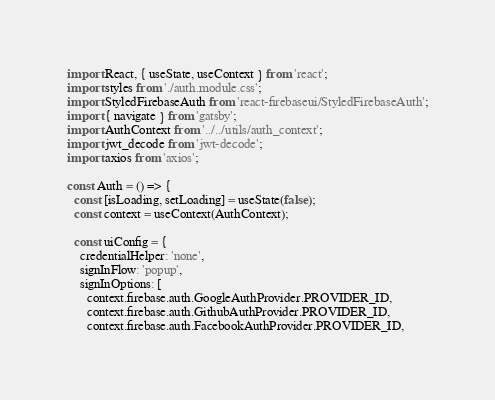Convert code to text. <code><loc_0><loc_0><loc_500><loc_500><_JavaScript_>import React, { useState, useContext } from 'react';
import styles from './auth.module.css';
import StyledFirebaseAuth from 'react-firebaseui/StyledFirebaseAuth';
import { navigate } from 'gatsby';
import AuthContext from '../../utils/auth_context';
import jwt_decode from 'jwt-decode';
import axios from 'axios';

const Auth = () => {
  const [isLoading, setLoading] = useState(false);
  const context = useContext(AuthContext);

  const uiConfig = {
    credentialHelper: 'none',
    signInFlow: 'popup',
    signInOptions: [
      context.firebase.auth.GoogleAuthProvider.PROVIDER_ID,
      context.firebase.auth.GithubAuthProvider.PROVIDER_ID,
      context.firebase.auth.FacebookAuthProvider.PROVIDER_ID,</code> 